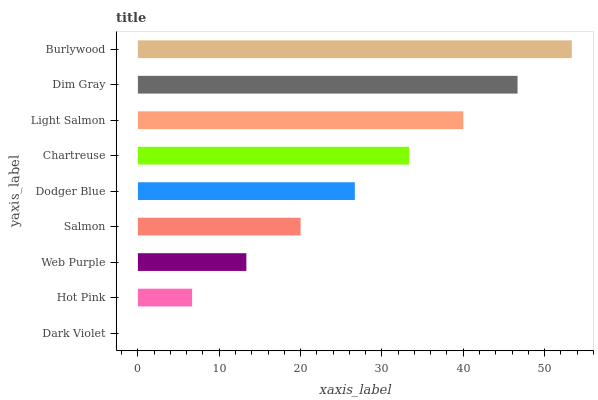Is Dark Violet the minimum?
Answer yes or no. Yes. Is Burlywood the maximum?
Answer yes or no. Yes. Is Hot Pink the minimum?
Answer yes or no. No. Is Hot Pink the maximum?
Answer yes or no. No. Is Hot Pink greater than Dark Violet?
Answer yes or no. Yes. Is Dark Violet less than Hot Pink?
Answer yes or no. Yes. Is Dark Violet greater than Hot Pink?
Answer yes or no. No. Is Hot Pink less than Dark Violet?
Answer yes or no. No. Is Dodger Blue the high median?
Answer yes or no. Yes. Is Dodger Blue the low median?
Answer yes or no. Yes. Is Hot Pink the high median?
Answer yes or no. No. Is Hot Pink the low median?
Answer yes or no. No. 